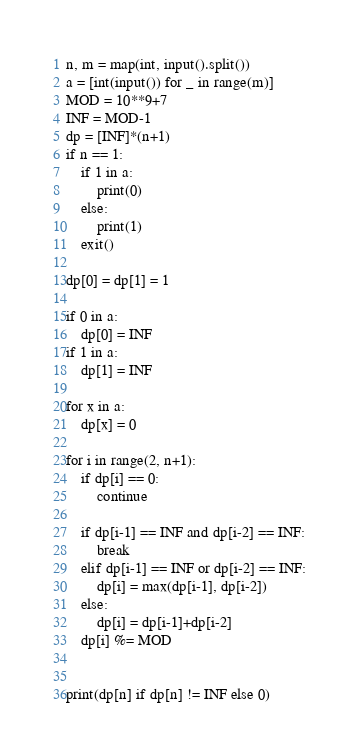Convert code to text. <code><loc_0><loc_0><loc_500><loc_500><_Python_>n, m = map(int, input().split())
a = [int(input()) for _ in range(m)]
MOD = 10**9+7
INF = MOD-1
dp = [INF]*(n+1)
if n == 1:
    if 1 in a:
        print(0)
    else:
        print(1)
    exit()

dp[0] = dp[1] = 1

if 0 in a:
    dp[0] = INF
if 1 in a:
    dp[1] = INF

for x in a:
    dp[x] = 0

for i in range(2, n+1):
    if dp[i] == 0:
        continue

    if dp[i-1] == INF and dp[i-2] == INF:
        break
    elif dp[i-1] == INF or dp[i-2] == INF:
        dp[i] = max(dp[i-1], dp[i-2])
    else:
        dp[i] = dp[i-1]+dp[i-2]
    dp[i] %= MOD


print(dp[n] if dp[n] != INF else 0)
</code> 